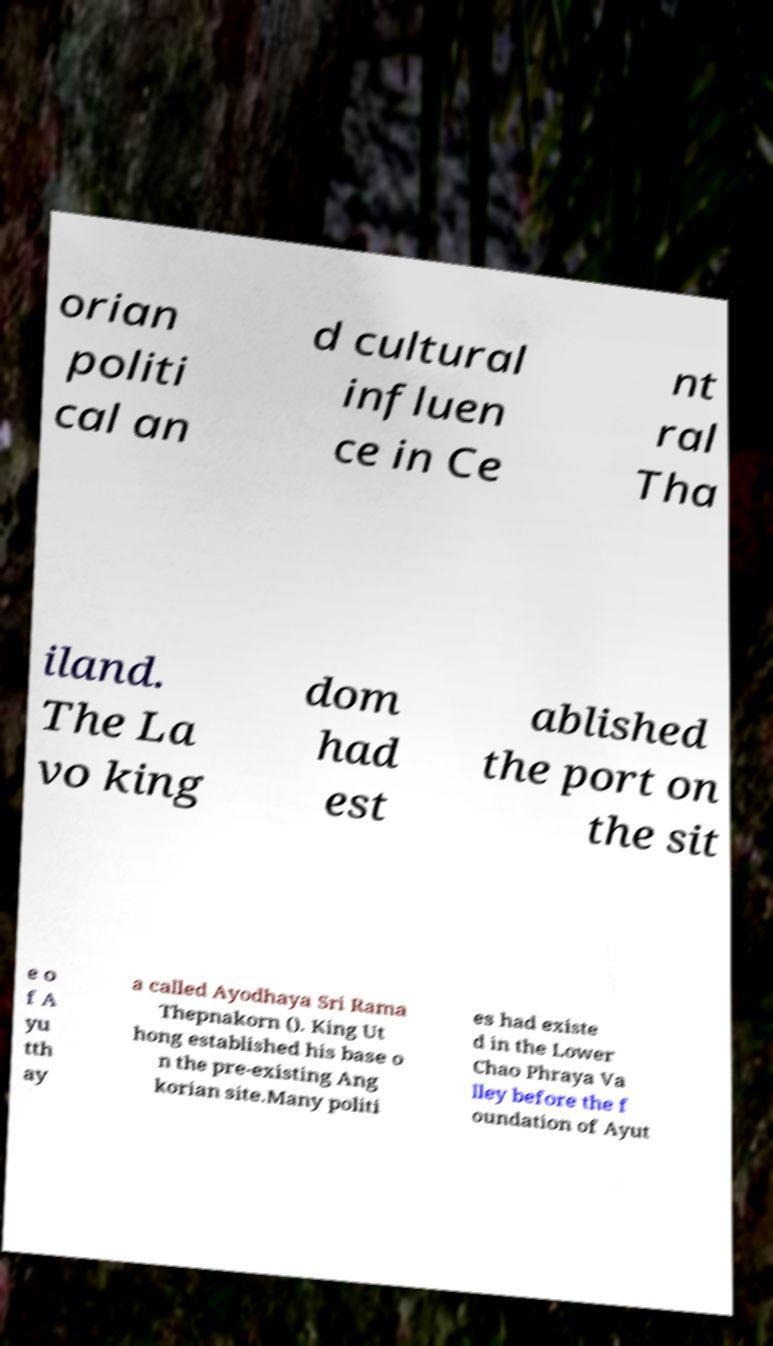There's text embedded in this image that I need extracted. Can you transcribe it verbatim? orian politi cal an d cultural influen ce in Ce nt ral Tha iland. The La vo king dom had est ablished the port on the sit e o f A yu tth ay a called Ayodhaya Sri Rama Thepnakorn (). King Ut hong established his base o n the pre-existing Ang korian site.Many politi es had existe d in the Lower Chao Phraya Va lley before the f oundation of Ayut 